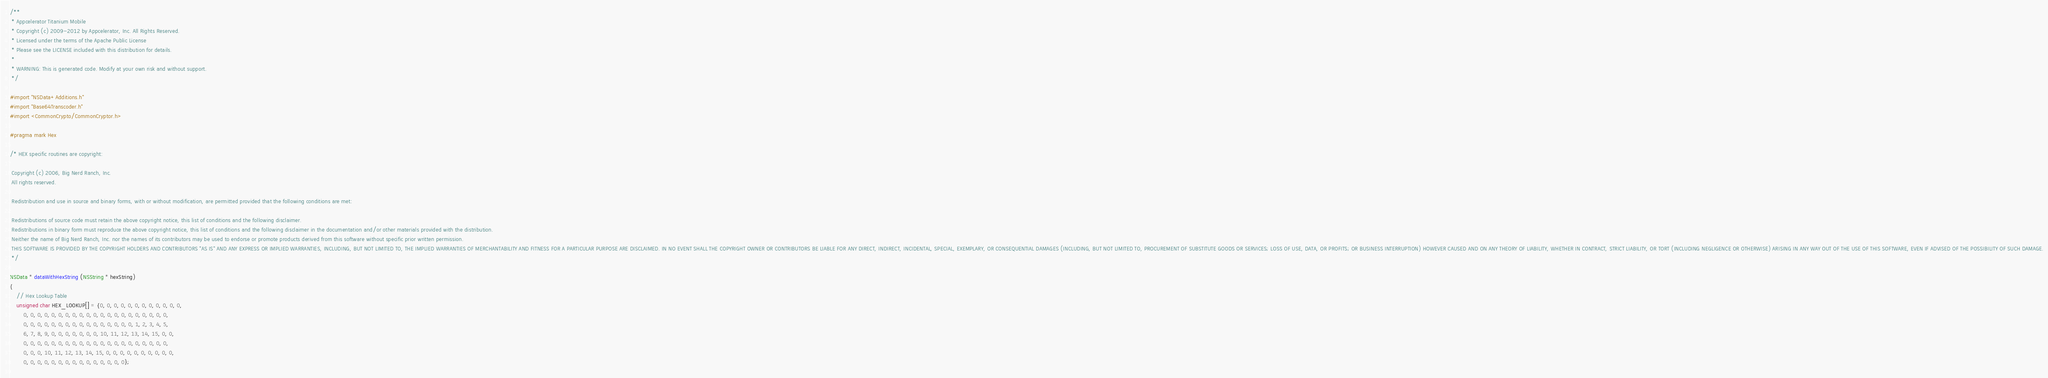<code> <loc_0><loc_0><loc_500><loc_500><_ObjectiveC_>/**
 * Appcelerator Titanium Mobile
 * Copyright (c) 2009-2012 by Appcelerator, Inc. All Rights Reserved.
 * Licensed under the terms of the Apache Public License
 * Please see the LICENSE included with this distribution for details.
 * 
 * WARNING: This is generated code. Modify at your own risk and without support.
 */

#import "NSData+Additions.h"
#import "Base64Transcoder.h"
#import <CommonCrypto/CommonCryptor.h>

#pragma mark Hex

/* HEX specific routines are copyright:
 
 Copyright (c) 2006, Big Nerd Ranch, Inc.
 All rights reserved.
 
 Redistribution and use in source and binary forms, with or without modification, are permitted provided that the following conditions are met:
 
 Redistributions of source code must retain the above copyright notice, this list of conditions and the following disclaimer.
 Redistributions in binary form must reproduce the above copyright notice, this list of conditions and the following disclaimer in the documentation and/or other materials provided with the distribution.
 Neither the name of Big Nerd Ranch, Inc. nor the names of its contributors may be used to endorse or promote products derived from this software without specific prior written permission.
 THIS SOFTWARE IS PROVIDED BY THE COPYRIGHT HOLDERS AND CONTRIBUTORS "AS IS" AND ANY EXPRESS OR IMPLIED WARRANTIES, INCLUDING, BUT NOT LIMITED TO, THE IMPLIED WARRANTIES OF MERCHANTABILITY AND FITNESS FOR A PARTICULAR PURPOSE ARE DISCLAIMED. IN NO EVENT SHALL THE COPYRIGHT OWNER OR CONTRIBUTORS BE LIABLE FOR ANY DIRECT, INDIRECT, INCIDENTAL, SPECIAL, EXEMPLARY, OR CONSEQUENTIAL DAMAGES (INCLUDING, BUT NOT LIMITED TO, PROCUREMENT OF SUBSTITUTE GOODS OR SERVICES; LOSS OF USE, DATA, OR PROFITS; OR BUSINESS INTERRUPTION) HOWEVER CAUSED AND ON ANY THEORY OF LIABILITY, WHETHER IN CONTRACT, STRICT LIABILITY, OR TORT (INCLUDING NEGLIGENCE OR OTHERWISE) ARISING IN ANY WAY OUT OF THE USE OF THIS SOFTWARE, EVEN IF ADVISED OF THE POSSIBILITY OF SUCH DAMAGE.
 */

NSData * dataWithHexString (NSString * hexString)
{	
	// Hex Lookup Table
	unsigned char HEX_LOOKUP[] = {0, 0, 0, 0, 0, 0, 0, 0, 0, 0, 0, 0, 
		0, 0, 0, 0, 0, 0, 0, 0, 0, 0, 0, 0, 0, 0, 0, 0, 0, 0, 0, 0, 0, 
		0, 0, 0, 0, 0, 0, 0, 0, 0, 0, 0, 0, 0, 0, 0, 0, 1, 2, 3, 4, 5, 
		6, 7, 8, 9, 0, 0, 0, 0, 0, 0, 0, 10, 11, 12, 13, 14, 15, 0, 0, 
		0, 0, 0, 0, 0, 0, 0, 0, 0, 0, 0, 0, 0, 0, 0, 0, 0, 0, 0, 0, 0, 
		0, 0, 0, 10, 11, 12, 13, 14, 15, 0, 0, 0, 0, 0, 0, 0, 0, 0, 0, 
		0, 0, 0, 0, 0, 0, 0, 0, 0, 0, 0, 0, 0, 0, 0};
	</code> 